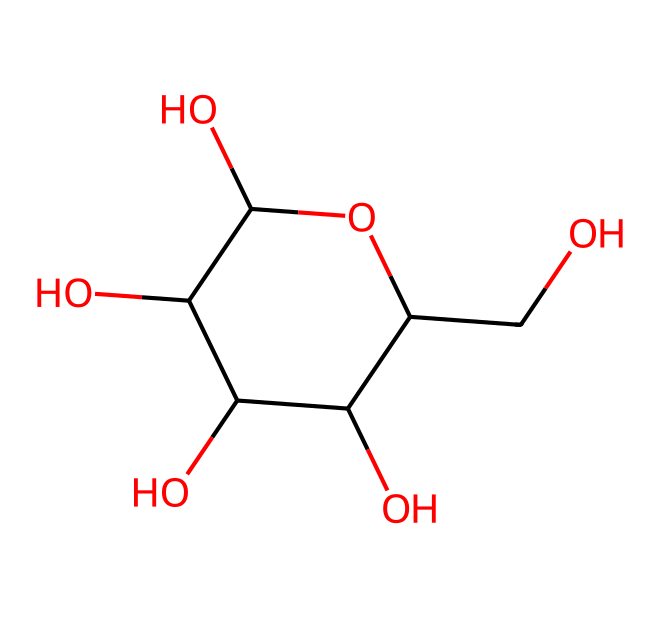What is the molecular formula of glucose? To determine the molecular formula, count the number of carbon (C), hydrogen (H), and oxygen (O) atoms in the structure. The structure shows 6 carbon atoms, 12 hydrogen atoms, and 6 oxygen atoms, which gives the molecular formula as C6H12O6.
Answer: C6H12O6 How many hydroxyl groups (-OH) are present in glucose? By examining the chemical structure, I can identify the hydroxyl groups present by locating each -OH group attached to the carbon atoms. In the glucose structure, there are 5 hydroxyl groups in total.
Answer: 5 Which type of carbohydrate does glucose represent? Glucose is a monosaccharide, which is the simplest form of carbohydrates that cannot be hydrolyzed into simpler sugars. It consists of a single sugar unit, evident from its structure lacking glycosidic bonds between multiple sugar units.
Answer: monosaccharide How many rings are in the structure of glucose? In the chemical structure, glucose has a cyclic (ring) form, as indicated by the connectivity of carbons and the oxygen that closes the ring. Therefore, it contains one ring.
Answer: 1 What is the ring structure type of glucose? The structure of glucose indicates it is a pyranose since it forms a six-membered ring that includes one oxygen atom and five carbon atoms. This is characteristic of pyranose sugars.
Answer: pyranose Which part of glucose is responsible for its sweetness? The sweetness of glucose is primarily attributed to its specific molecular arrangement and the presence of hydroxyl groups that interact with taste receptors. This unique arrangement indicates its classification as a simple sugar that is perceived as sweet.
Answer: hydroxyl groups 